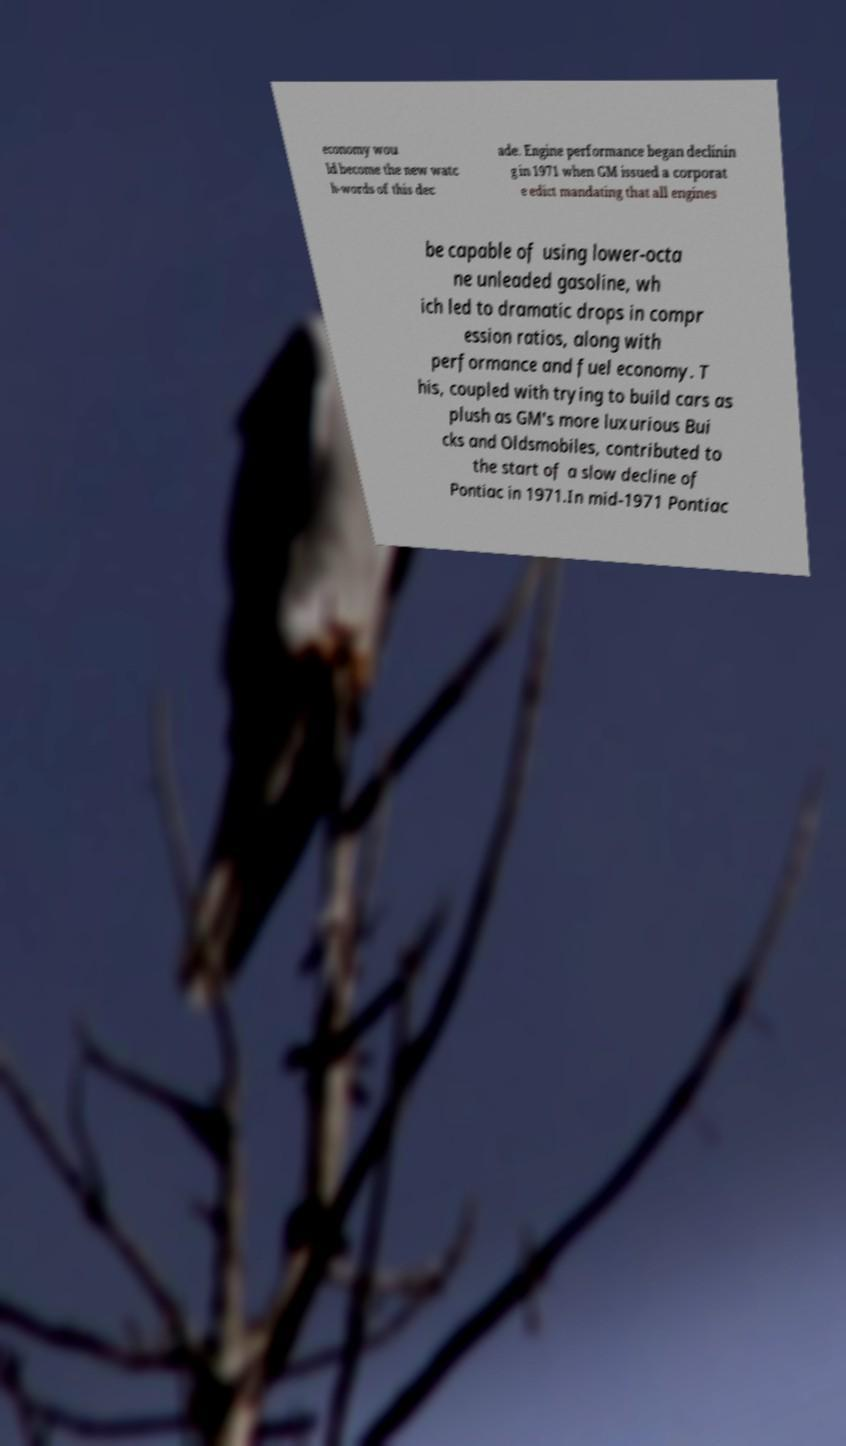I need the written content from this picture converted into text. Can you do that? economy wou ld become the new watc h-words of this dec ade. Engine performance began declinin g in 1971 when GM issued a corporat e edict mandating that all engines be capable of using lower-octa ne unleaded gasoline, wh ich led to dramatic drops in compr ession ratios, along with performance and fuel economy. T his, coupled with trying to build cars as plush as GM's more luxurious Bui cks and Oldsmobiles, contributed to the start of a slow decline of Pontiac in 1971.In mid-1971 Pontiac 